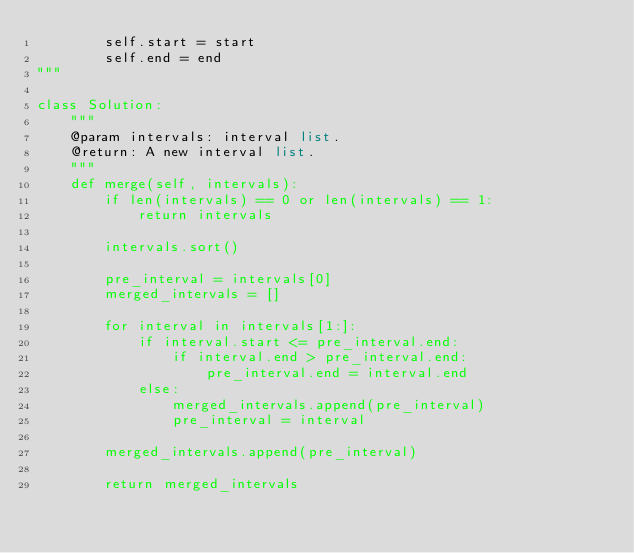<code> <loc_0><loc_0><loc_500><loc_500><_Python_>        self.start = start
        self.end = end
"""

class Solution:
    """
    @param intervals: interval list.
    @return: A new interval list.
    """
    def merge(self, intervals):
        if len(intervals) == 0 or len(intervals) == 1:
            return intervals
            
        intervals.sort()
            
        pre_interval = intervals[0]
        merged_intervals = []
        
        for interval in intervals[1:]:
            if interval.start <= pre_interval.end:
                if interval.end > pre_interval.end:
                    pre_interval.end = interval.end
            else:
                merged_intervals.append(pre_interval)
                pre_interval = interval
        
        merged_intervals.append(pre_interval)
        
        return merged_intervals</code> 